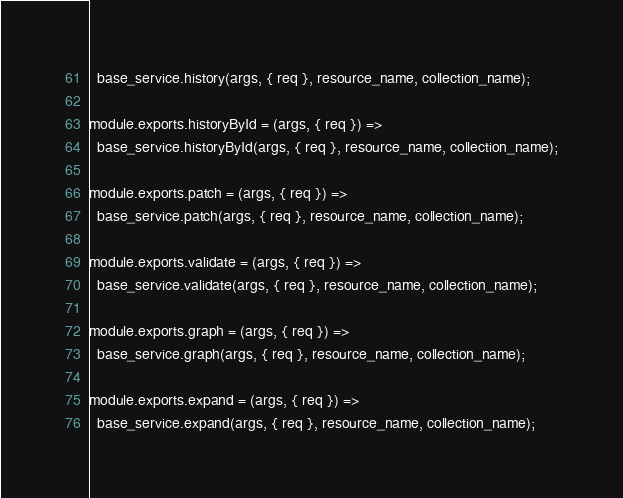<code> <loc_0><loc_0><loc_500><loc_500><_JavaScript_>  base_service.history(args, { req }, resource_name, collection_name);

module.exports.historyById = (args, { req }) =>
  base_service.historyById(args, { req }, resource_name, collection_name);

module.exports.patch = (args, { req }) =>
  base_service.patch(args, { req }, resource_name, collection_name);

module.exports.validate = (args, { req }) =>
  base_service.validate(args, { req }, resource_name, collection_name);

module.exports.graph = (args, { req }) =>
  base_service.graph(args, { req }, resource_name, collection_name);

module.exports.expand = (args, { req }) =>
  base_service.expand(args, { req }, resource_name, collection_name);


</code> 